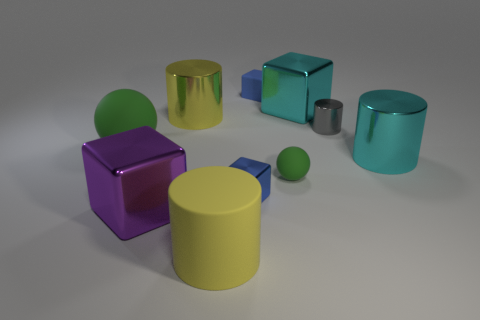What is the material of the other large yellow object that is the same shape as the big yellow shiny object?
Provide a short and direct response. Rubber. Do the cyan object to the left of the gray shiny cylinder and the tiny gray thing have the same size?
Make the answer very short. No. There is a big purple metallic thing; how many matte objects are left of it?
Provide a succinct answer. 1. Are there fewer yellow cylinders behind the tiny blue matte cube than small blue shiny blocks that are behind the tiny green rubber thing?
Your answer should be very brief. No. How many tiny matte cylinders are there?
Provide a short and direct response. 0. There is a big shiny block on the right side of the large yellow matte object; what color is it?
Make the answer very short. Cyan. The cyan block is what size?
Keep it short and to the point. Large. Does the big rubber sphere have the same color as the matte sphere on the right side of the large yellow matte thing?
Your response must be concise. Yes. What is the color of the large matte thing that is to the left of the cylinder that is in front of the purple shiny block?
Give a very brief answer. Green. Are there any other things that have the same size as the yellow metallic thing?
Provide a succinct answer. Yes. 